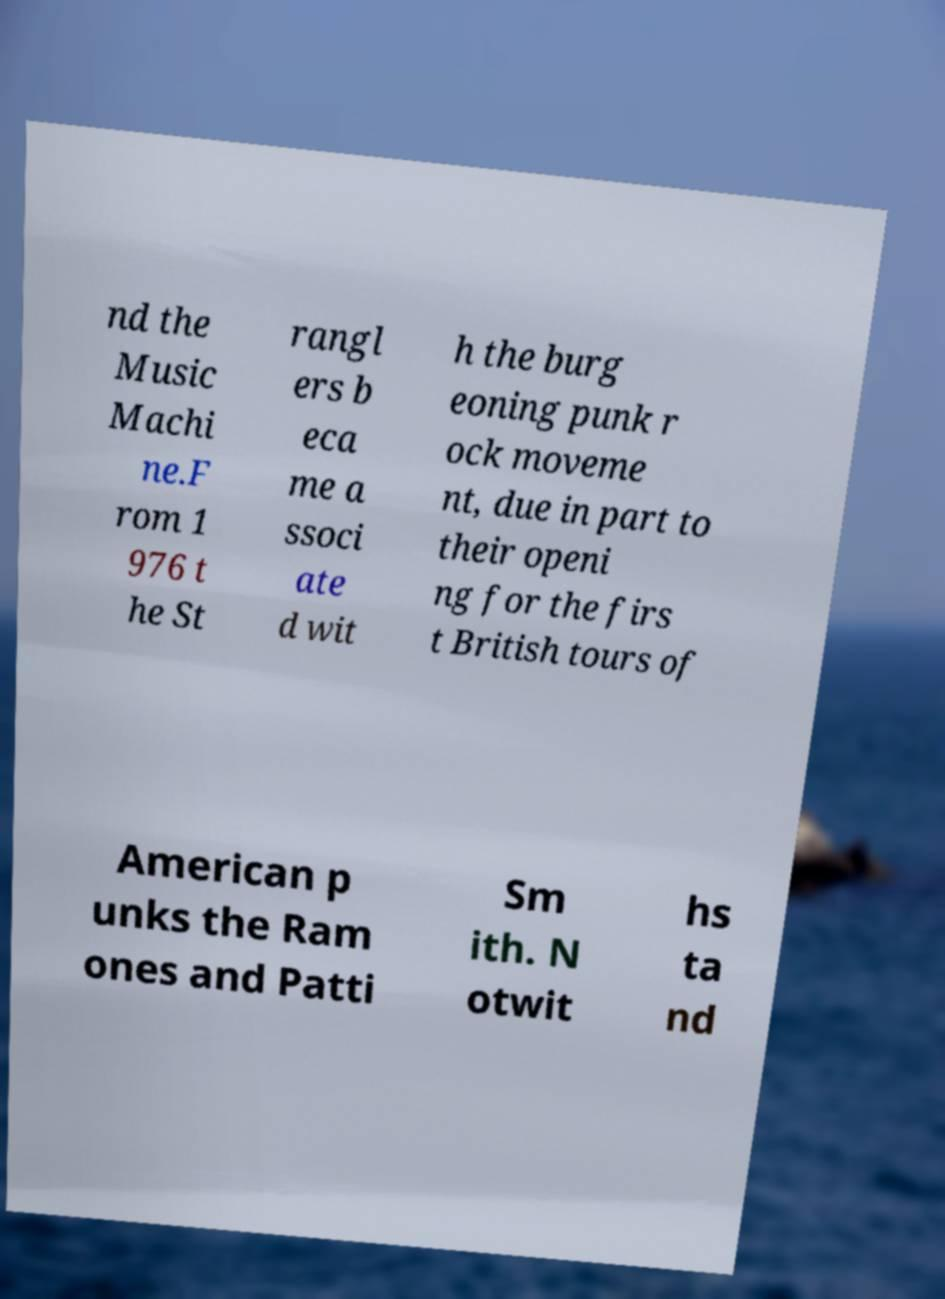Can you accurately transcribe the text from the provided image for me? nd the Music Machi ne.F rom 1 976 t he St rangl ers b eca me a ssoci ate d wit h the burg eoning punk r ock moveme nt, due in part to their openi ng for the firs t British tours of American p unks the Ram ones and Patti Sm ith. N otwit hs ta nd 